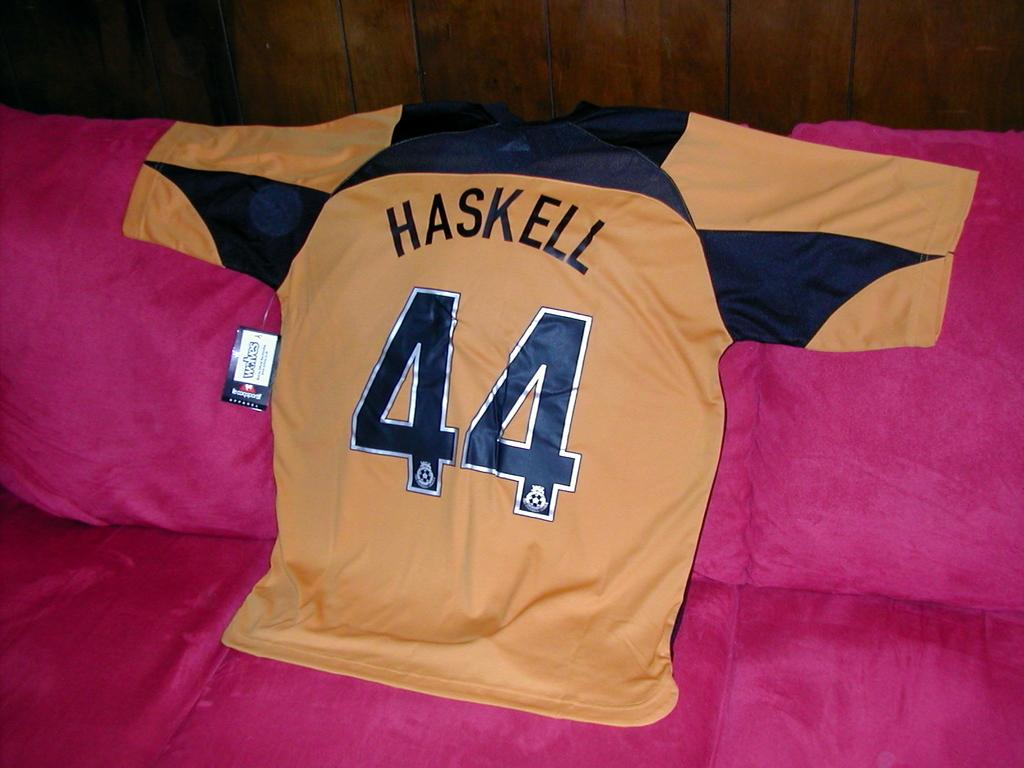<image>
Describe the image concisely. The player name on the jersey is Haskell and is number 44 